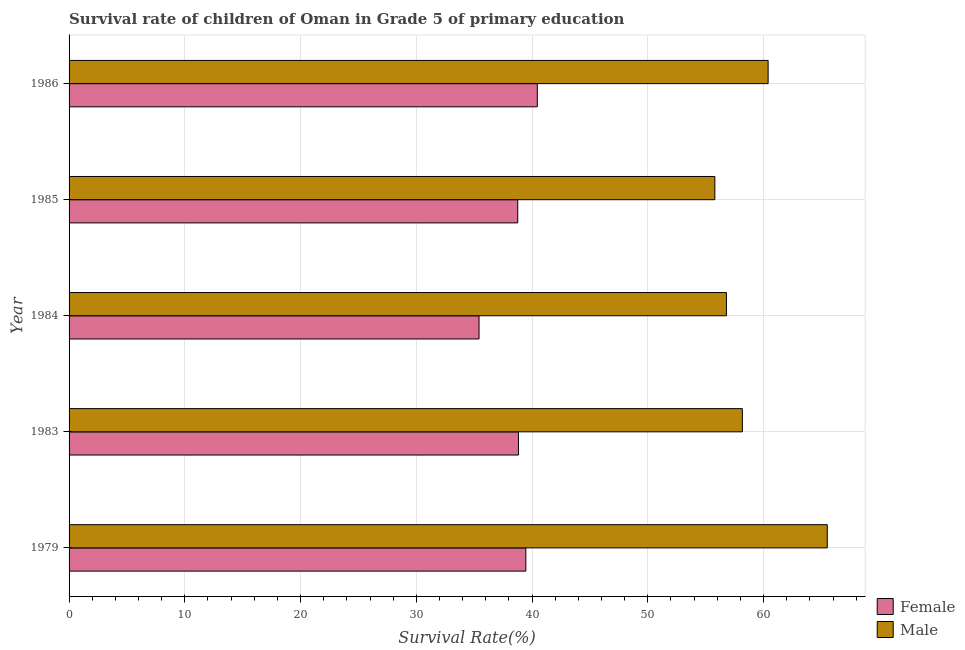Are the number of bars per tick equal to the number of legend labels?
Keep it short and to the point. Yes. Are the number of bars on each tick of the Y-axis equal?
Provide a short and direct response. Yes. How many bars are there on the 5th tick from the top?
Make the answer very short. 2. What is the label of the 1st group of bars from the top?
Make the answer very short. 1986. In how many cases, is the number of bars for a given year not equal to the number of legend labels?
Provide a short and direct response. 0. What is the survival rate of female students in primary education in 1986?
Make the answer very short. 40.45. Across all years, what is the maximum survival rate of female students in primary education?
Ensure brevity in your answer.  40.45. Across all years, what is the minimum survival rate of male students in primary education?
Provide a succinct answer. 55.79. In which year was the survival rate of male students in primary education maximum?
Keep it short and to the point. 1979. In which year was the survival rate of male students in primary education minimum?
Make the answer very short. 1985. What is the total survival rate of female students in primary education in the graph?
Offer a terse response. 192.91. What is the difference between the survival rate of female students in primary education in 1979 and that in 1983?
Provide a succinct answer. 0.64. What is the difference between the survival rate of female students in primary education in 1979 and the survival rate of male students in primary education in 1983?
Your answer should be very brief. -18.7. What is the average survival rate of female students in primary education per year?
Offer a very short reply. 38.58. In the year 1984, what is the difference between the survival rate of male students in primary education and survival rate of female students in primary education?
Your response must be concise. 21.37. In how many years, is the survival rate of male students in primary education greater than 18 %?
Your response must be concise. 5. Is the survival rate of female students in primary education in 1979 less than that in 1986?
Provide a succinct answer. Yes. What is the difference between the highest and the second highest survival rate of male students in primary education?
Your answer should be very brief. 5.11. What is the difference between the highest and the lowest survival rate of male students in primary education?
Offer a very short reply. 9.71. In how many years, is the survival rate of female students in primary education greater than the average survival rate of female students in primary education taken over all years?
Offer a very short reply. 4. How many bars are there?
Make the answer very short. 10. How many years are there in the graph?
Give a very brief answer. 5. What is the difference between two consecutive major ticks on the X-axis?
Your response must be concise. 10. Does the graph contain any zero values?
Offer a terse response. No. Does the graph contain grids?
Your answer should be very brief. Yes. Where does the legend appear in the graph?
Your answer should be very brief. Bottom right. What is the title of the graph?
Offer a terse response. Survival rate of children of Oman in Grade 5 of primary education. What is the label or title of the X-axis?
Your response must be concise. Survival Rate(%). What is the Survival Rate(%) in Female in 1979?
Ensure brevity in your answer.  39.46. What is the Survival Rate(%) in Male in 1979?
Offer a terse response. 65.5. What is the Survival Rate(%) of Female in 1983?
Ensure brevity in your answer.  38.82. What is the Survival Rate(%) of Male in 1983?
Your response must be concise. 58.17. What is the Survival Rate(%) of Female in 1984?
Your answer should be compact. 35.42. What is the Survival Rate(%) of Male in 1984?
Ensure brevity in your answer.  56.79. What is the Survival Rate(%) of Female in 1985?
Provide a short and direct response. 38.76. What is the Survival Rate(%) of Male in 1985?
Ensure brevity in your answer.  55.79. What is the Survival Rate(%) of Female in 1986?
Your answer should be very brief. 40.45. What is the Survival Rate(%) of Male in 1986?
Your answer should be compact. 60.39. Across all years, what is the maximum Survival Rate(%) in Female?
Make the answer very short. 40.45. Across all years, what is the maximum Survival Rate(%) in Male?
Offer a terse response. 65.5. Across all years, what is the minimum Survival Rate(%) in Female?
Offer a very short reply. 35.42. Across all years, what is the minimum Survival Rate(%) in Male?
Give a very brief answer. 55.79. What is the total Survival Rate(%) of Female in the graph?
Your answer should be very brief. 192.91. What is the total Survival Rate(%) in Male in the graph?
Offer a terse response. 296.64. What is the difference between the Survival Rate(%) in Female in 1979 and that in 1983?
Provide a short and direct response. 0.64. What is the difference between the Survival Rate(%) in Male in 1979 and that in 1983?
Offer a terse response. 7.34. What is the difference between the Survival Rate(%) of Female in 1979 and that in 1984?
Provide a short and direct response. 4.04. What is the difference between the Survival Rate(%) in Male in 1979 and that in 1984?
Provide a succinct answer. 8.71. What is the difference between the Survival Rate(%) in Female in 1979 and that in 1985?
Provide a short and direct response. 0.7. What is the difference between the Survival Rate(%) of Male in 1979 and that in 1985?
Offer a terse response. 9.71. What is the difference between the Survival Rate(%) in Female in 1979 and that in 1986?
Your answer should be very brief. -0.99. What is the difference between the Survival Rate(%) of Male in 1979 and that in 1986?
Your answer should be compact. 5.11. What is the difference between the Survival Rate(%) in Female in 1983 and that in 1984?
Give a very brief answer. 3.4. What is the difference between the Survival Rate(%) of Male in 1983 and that in 1984?
Keep it short and to the point. 1.38. What is the difference between the Survival Rate(%) of Female in 1983 and that in 1985?
Your answer should be very brief. 0.06. What is the difference between the Survival Rate(%) of Male in 1983 and that in 1985?
Ensure brevity in your answer.  2.38. What is the difference between the Survival Rate(%) of Female in 1983 and that in 1986?
Keep it short and to the point. -1.63. What is the difference between the Survival Rate(%) of Male in 1983 and that in 1986?
Your response must be concise. -2.23. What is the difference between the Survival Rate(%) in Female in 1984 and that in 1985?
Give a very brief answer. -3.34. What is the difference between the Survival Rate(%) in Male in 1984 and that in 1985?
Your answer should be very brief. 1. What is the difference between the Survival Rate(%) in Female in 1984 and that in 1986?
Provide a succinct answer. -5.03. What is the difference between the Survival Rate(%) of Male in 1984 and that in 1986?
Give a very brief answer. -3.6. What is the difference between the Survival Rate(%) of Female in 1985 and that in 1986?
Ensure brevity in your answer.  -1.69. What is the difference between the Survival Rate(%) of Male in 1985 and that in 1986?
Make the answer very short. -4.6. What is the difference between the Survival Rate(%) of Female in 1979 and the Survival Rate(%) of Male in 1983?
Make the answer very short. -18.7. What is the difference between the Survival Rate(%) of Female in 1979 and the Survival Rate(%) of Male in 1984?
Your answer should be very brief. -17.33. What is the difference between the Survival Rate(%) in Female in 1979 and the Survival Rate(%) in Male in 1985?
Ensure brevity in your answer.  -16.33. What is the difference between the Survival Rate(%) in Female in 1979 and the Survival Rate(%) in Male in 1986?
Make the answer very short. -20.93. What is the difference between the Survival Rate(%) in Female in 1983 and the Survival Rate(%) in Male in 1984?
Your answer should be very brief. -17.97. What is the difference between the Survival Rate(%) in Female in 1983 and the Survival Rate(%) in Male in 1985?
Offer a very short reply. -16.97. What is the difference between the Survival Rate(%) in Female in 1983 and the Survival Rate(%) in Male in 1986?
Provide a short and direct response. -21.57. What is the difference between the Survival Rate(%) in Female in 1984 and the Survival Rate(%) in Male in 1985?
Provide a succinct answer. -20.37. What is the difference between the Survival Rate(%) of Female in 1984 and the Survival Rate(%) of Male in 1986?
Ensure brevity in your answer.  -24.97. What is the difference between the Survival Rate(%) of Female in 1985 and the Survival Rate(%) of Male in 1986?
Your answer should be compact. -21.63. What is the average Survival Rate(%) in Female per year?
Your answer should be compact. 38.58. What is the average Survival Rate(%) in Male per year?
Offer a terse response. 59.33. In the year 1979, what is the difference between the Survival Rate(%) in Female and Survival Rate(%) in Male?
Offer a very short reply. -26.04. In the year 1983, what is the difference between the Survival Rate(%) of Female and Survival Rate(%) of Male?
Keep it short and to the point. -19.34. In the year 1984, what is the difference between the Survival Rate(%) in Female and Survival Rate(%) in Male?
Make the answer very short. -21.37. In the year 1985, what is the difference between the Survival Rate(%) in Female and Survival Rate(%) in Male?
Keep it short and to the point. -17.03. In the year 1986, what is the difference between the Survival Rate(%) in Female and Survival Rate(%) in Male?
Ensure brevity in your answer.  -19.94. What is the ratio of the Survival Rate(%) in Female in 1979 to that in 1983?
Provide a succinct answer. 1.02. What is the ratio of the Survival Rate(%) of Male in 1979 to that in 1983?
Offer a very short reply. 1.13. What is the ratio of the Survival Rate(%) of Female in 1979 to that in 1984?
Provide a short and direct response. 1.11. What is the ratio of the Survival Rate(%) in Male in 1979 to that in 1984?
Provide a succinct answer. 1.15. What is the ratio of the Survival Rate(%) of Female in 1979 to that in 1985?
Keep it short and to the point. 1.02. What is the ratio of the Survival Rate(%) in Male in 1979 to that in 1985?
Your answer should be compact. 1.17. What is the ratio of the Survival Rate(%) in Female in 1979 to that in 1986?
Provide a short and direct response. 0.98. What is the ratio of the Survival Rate(%) in Male in 1979 to that in 1986?
Give a very brief answer. 1.08. What is the ratio of the Survival Rate(%) of Female in 1983 to that in 1984?
Your answer should be compact. 1.1. What is the ratio of the Survival Rate(%) in Male in 1983 to that in 1984?
Offer a terse response. 1.02. What is the ratio of the Survival Rate(%) of Female in 1983 to that in 1985?
Keep it short and to the point. 1. What is the ratio of the Survival Rate(%) in Male in 1983 to that in 1985?
Your response must be concise. 1.04. What is the ratio of the Survival Rate(%) of Female in 1983 to that in 1986?
Your answer should be very brief. 0.96. What is the ratio of the Survival Rate(%) in Male in 1983 to that in 1986?
Your answer should be compact. 0.96. What is the ratio of the Survival Rate(%) of Female in 1984 to that in 1985?
Provide a short and direct response. 0.91. What is the ratio of the Survival Rate(%) in Male in 1984 to that in 1985?
Offer a very short reply. 1.02. What is the ratio of the Survival Rate(%) of Female in 1984 to that in 1986?
Your answer should be compact. 0.88. What is the ratio of the Survival Rate(%) of Male in 1984 to that in 1986?
Give a very brief answer. 0.94. What is the ratio of the Survival Rate(%) in Female in 1985 to that in 1986?
Offer a terse response. 0.96. What is the ratio of the Survival Rate(%) of Male in 1985 to that in 1986?
Offer a very short reply. 0.92. What is the difference between the highest and the second highest Survival Rate(%) of Male?
Offer a terse response. 5.11. What is the difference between the highest and the lowest Survival Rate(%) in Female?
Provide a short and direct response. 5.03. What is the difference between the highest and the lowest Survival Rate(%) of Male?
Make the answer very short. 9.71. 